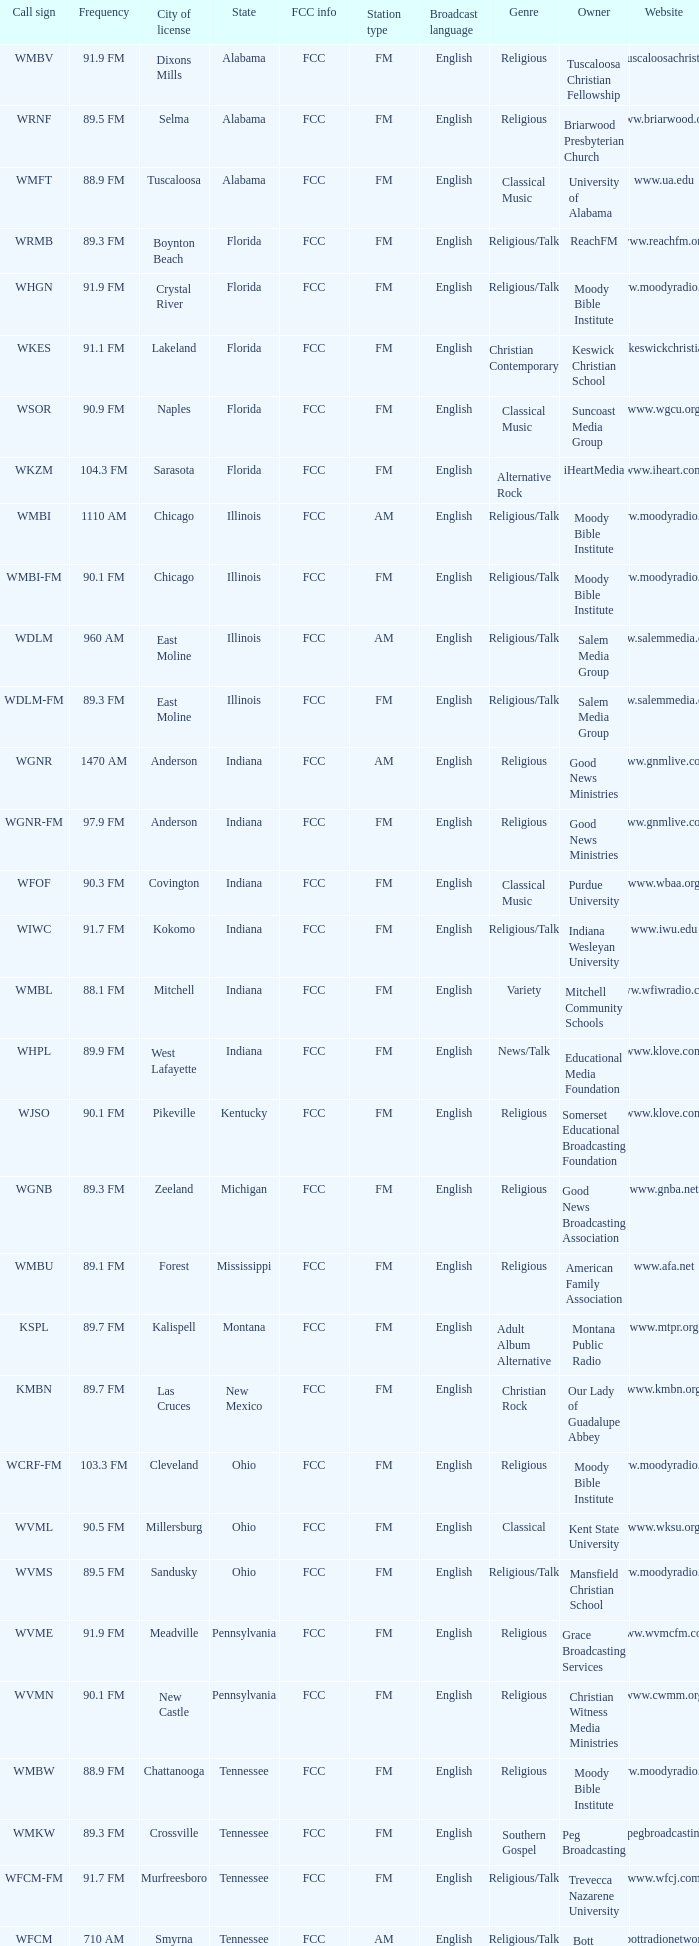What is the frequency of the radio station in Indiana that has a call sign of WGNR? 1470 AM. 